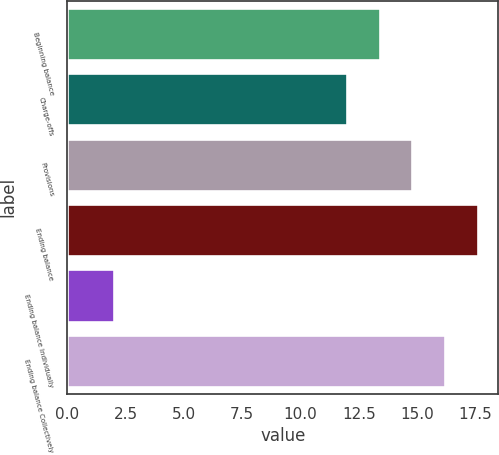<chart> <loc_0><loc_0><loc_500><loc_500><bar_chart><fcel>Beginning balance<fcel>Charge-offs<fcel>Provisions<fcel>Ending balance<fcel>Ending balance Individually<fcel>Ending balance Collectively<nl><fcel>13.4<fcel>12<fcel>14.8<fcel>17.6<fcel>2<fcel>16.2<nl></chart> 